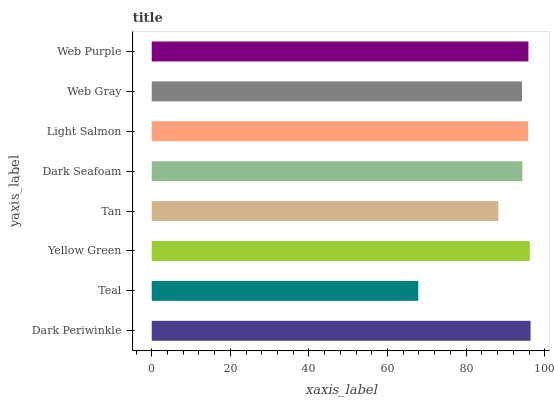Is Teal the minimum?
Answer yes or no. Yes. Is Dark Periwinkle the maximum?
Answer yes or no. Yes. Is Yellow Green the minimum?
Answer yes or no. No. Is Yellow Green the maximum?
Answer yes or no. No. Is Yellow Green greater than Teal?
Answer yes or no. Yes. Is Teal less than Yellow Green?
Answer yes or no. Yes. Is Teal greater than Yellow Green?
Answer yes or no. No. Is Yellow Green less than Teal?
Answer yes or no. No. Is Light Salmon the high median?
Answer yes or no. Yes. Is Dark Seafoam the low median?
Answer yes or no. Yes. Is Dark Seafoam the high median?
Answer yes or no. No. Is Dark Periwinkle the low median?
Answer yes or no. No. 